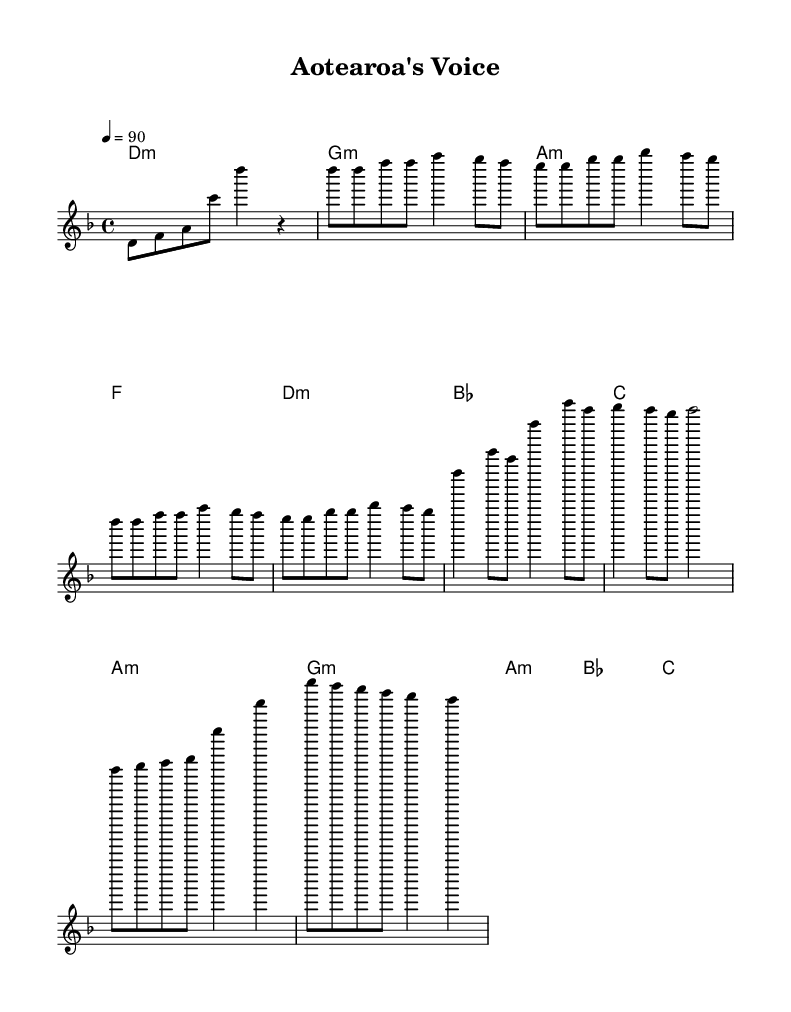what is the key signature of this music? The key signature is indicated at the beginning with a key of D minor, which typically has one flat, B flat.
Answer: D minor what is the time signature of this music? The time signature is found at the beginning, showing four beats per measure, indicated by 4/4.
Answer: 4/4 what is the tempo of this piece? The tempo is set at 90 beats per minute, noted in the music as "4 = 90".
Answer: 90 how many measures are in the verse section? The verse section repeats twice, and since there are eight measures in one complete take, the total measured in the verse is eight.
Answer: 8 what chord follows the D minor chord in the chorus? Looking at the harmonies, after the D minor chord, the next chord in the chorus progression is B flat.
Answer: B flat how does the melody of the bridge differ from the verse? The melody of the bridge contains different pitches and rhythm patterns compared to the verse, which consists of a repeated melodic line; the bridge introduces new notes starting from F to D.
Answer: New notes which cultural identity theme is represented in this hip hop piece? The lyrics focus on Maori political representation and cultural identity, reflecting the significance of these themes in New Zealand hip hop.
Answer: Maori representation 